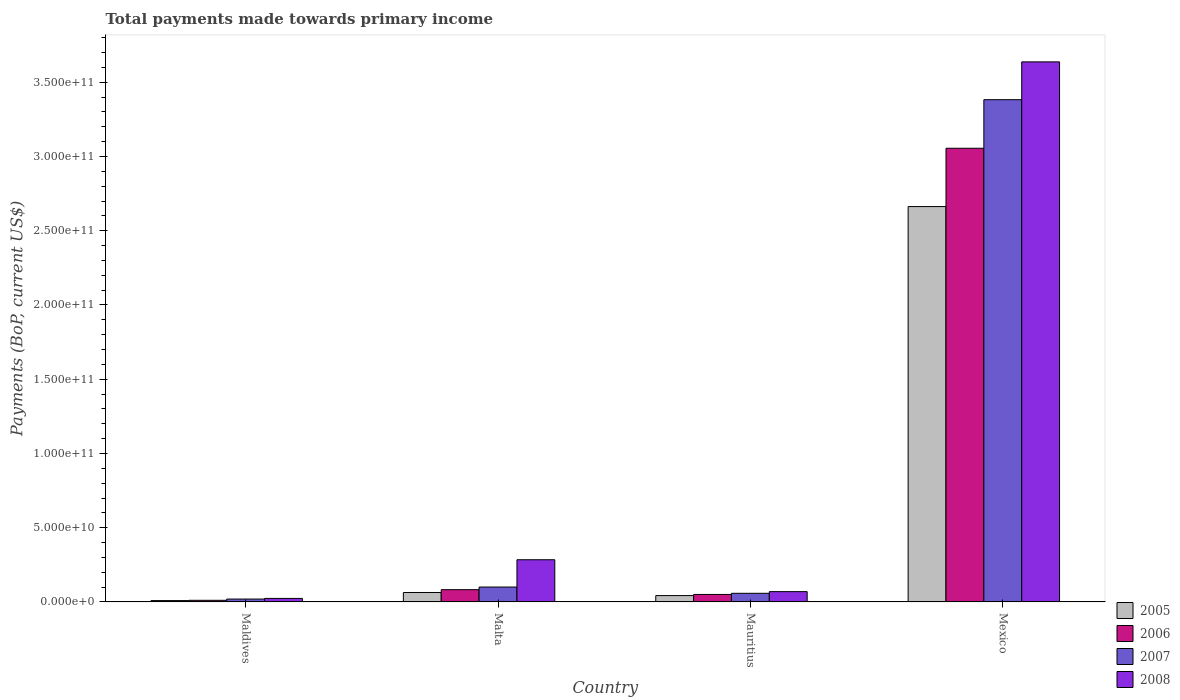How many different coloured bars are there?
Offer a very short reply. 4. How many groups of bars are there?
Give a very brief answer. 4. Are the number of bars on each tick of the X-axis equal?
Give a very brief answer. Yes. How many bars are there on the 4th tick from the left?
Offer a terse response. 4. How many bars are there on the 1st tick from the right?
Offer a terse response. 4. What is the label of the 3rd group of bars from the left?
Your answer should be compact. Mauritius. What is the total payments made towards primary income in 2007 in Malta?
Keep it short and to the point. 1.00e+1. Across all countries, what is the maximum total payments made towards primary income in 2007?
Your answer should be very brief. 3.38e+11. Across all countries, what is the minimum total payments made towards primary income in 2007?
Your answer should be very brief. 1.94e+09. In which country was the total payments made towards primary income in 2005 minimum?
Keep it short and to the point. Maldives. What is the total total payments made towards primary income in 2005 in the graph?
Make the answer very short. 2.78e+11. What is the difference between the total payments made towards primary income in 2007 in Maldives and that in Mexico?
Make the answer very short. -3.36e+11. What is the difference between the total payments made towards primary income in 2006 in Malta and the total payments made towards primary income in 2008 in Mauritius?
Offer a terse response. 1.32e+09. What is the average total payments made towards primary income in 2006 per country?
Make the answer very short. 8.00e+1. What is the difference between the total payments made towards primary income of/in 2005 and total payments made towards primary income of/in 2006 in Mexico?
Your response must be concise. -3.93e+1. In how many countries, is the total payments made towards primary income in 2006 greater than 10000000000 US$?
Provide a succinct answer. 1. What is the ratio of the total payments made towards primary income in 2008 in Maldives to that in Mexico?
Give a very brief answer. 0.01. What is the difference between the highest and the second highest total payments made towards primary income in 2006?
Ensure brevity in your answer.  -3.01e+11. What is the difference between the highest and the lowest total payments made towards primary income in 2008?
Provide a succinct answer. 3.61e+11. Is the sum of the total payments made towards primary income in 2005 in Malta and Mexico greater than the maximum total payments made towards primary income in 2006 across all countries?
Your response must be concise. No. Is it the case that in every country, the sum of the total payments made towards primary income in 2005 and total payments made towards primary income in 2006 is greater than the total payments made towards primary income in 2008?
Give a very brief answer. No. How many bars are there?
Ensure brevity in your answer.  16. Are all the bars in the graph horizontal?
Keep it short and to the point. No. How many countries are there in the graph?
Your answer should be compact. 4. Does the graph contain any zero values?
Ensure brevity in your answer.  No. Where does the legend appear in the graph?
Your answer should be very brief. Bottom right. What is the title of the graph?
Your response must be concise. Total payments made towards primary income. Does "1971" appear as one of the legend labels in the graph?
Make the answer very short. No. What is the label or title of the Y-axis?
Ensure brevity in your answer.  Payments (BoP, current US$). What is the Payments (BoP, current US$) in 2005 in Maldives?
Give a very brief answer. 9.10e+08. What is the Payments (BoP, current US$) in 2006 in Maldives?
Provide a short and direct response. 1.10e+09. What is the Payments (BoP, current US$) in 2007 in Maldives?
Provide a short and direct response. 1.94e+09. What is the Payments (BoP, current US$) in 2008 in Maldives?
Give a very brief answer. 2.38e+09. What is the Payments (BoP, current US$) in 2005 in Malta?
Provide a succinct answer. 6.37e+09. What is the Payments (BoP, current US$) of 2006 in Malta?
Offer a terse response. 8.26e+09. What is the Payments (BoP, current US$) in 2007 in Malta?
Give a very brief answer. 1.00e+1. What is the Payments (BoP, current US$) in 2008 in Malta?
Ensure brevity in your answer.  2.84e+1. What is the Payments (BoP, current US$) of 2005 in Mauritius?
Your response must be concise. 4.28e+09. What is the Payments (BoP, current US$) of 2006 in Mauritius?
Give a very brief answer. 5.05e+09. What is the Payments (BoP, current US$) of 2007 in Mauritius?
Your response must be concise. 5.82e+09. What is the Payments (BoP, current US$) in 2008 in Mauritius?
Your answer should be very brief. 6.95e+09. What is the Payments (BoP, current US$) in 2005 in Mexico?
Your response must be concise. 2.66e+11. What is the Payments (BoP, current US$) of 2006 in Mexico?
Provide a short and direct response. 3.06e+11. What is the Payments (BoP, current US$) in 2007 in Mexico?
Keep it short and to the point. 3.38e+11. What is the Payments (BoP, current US$) of 2008 in Mexico?
Provide a short and direct response. 3.64e+11. Across all countries, what is the maximum Payments (BoP, current US$) of 2005?
Your answer should be compact. 2.66e+11. Across all countries, what is the maximum Payments (BoP, current US$) of 2006?
Make the answer very short. 3.06e+11. Across all countries, what is the maximum Payments (BoP, current US$) of 2007?
Make the answer very short. 3.38e+11. Across all countries, what is the maximum Payments (BoP, current US$) of 2008?
Offer a terse response. 3.64e+11. Across all countries, what is the minimum Payments (BoP, current US$) of 2005?
Ensure brevity in your answer.  9.10e+08. Across all countries, what is the minimum Payments (BoP, current US$) of 2006?
Your answer should be very brief. 1.10e+09. Across all countries, what is the minimum Payments (BoP, current US$) of 2007?
Provide a short and direct response. 1.94e+09. Across all countries, what is the minimum Payments (BoP, current US$) of 2008?
Your response must be concise. 2.38e+09. What is the total Payments (BoP, current US$) of 2005 in the graph?
Your answer should be very brief. 2.78e+11. What is the total Payments (BoP, current US$) in 2006 in the graph?
Your answer should be very brief. 3.20e+11. What is the total Payments (BoP, current US$) of 2007 in the graph?
Your answer should be very brief. 3.56e+11. What is the total Payments (BoP, current US$) of 2008 in the graph?
Ensure brevity in your answer.  4.01e+11. What is the difference between the Payments (BoP, current US$) in 2005 in Maldives and that in Malta?
Give a very brief answer. -5.46e+09. What is the difference between the Payments (BoP, current US$) of 2006 in Maldives and that in Malta?
Provide a succinct answer. -7.16e+09. What is the difference between the Payments (BoP, current US$) in 2007 in Maldives and that in Malta?
Ensure brevity in your answer.  -8.10e+09. What is the difference between the Payments (BoP, current US$) of 2008 in Maldives and that in Malta?
Your response must be concise. -2.60e+1. What is the difference between the Payments (BoP, current US$) in 2005 in Maldives and that in Mauritius?
Your answer should be very brief. -3.37e+09. What is the difference between the Payments (BoP, current US$) of 2006 in Maldives and that in Mauritius?
Your answer should be compact. -3.95e+09. What is the difference between the Payments (BoP, current US$) of 2007 in Maldives and that in Mauritius?
Your response must be concise. -3.88e+09. What is the difference between the Payments (BoP, current US$) of 2008 in Maldives and that in Mauritius?
Your answer should be very brief. -4.57e+09. What is the difference between the Payments (BoP, current US$) in 2005 in Maldives and that in Mexico?
Your answer should be very brief. -2.65e+11. What is the difference between the Payments (BoP, current US$) of 2006 in Maldives and that in Mexico?
Offer a very short reply. -3.04e+11. What is the difference between the Payments (BoP, current US$) in 2007 in Maldives and that in Mexico?
Keep it short and to the point. -3.36e+11. What is the difference between the Payments (BoP, current US$) of 2008 in Maldives and that in Mexico?
Offer a terse response. -3.61e+11. What is the difference between the Payments (BoP, current US$) of 2005 in Malta and that in Mauritius?
Your response must be concise. 2.08e+09. What is the difference between the Payments (BoP, current US$) in 2006 in Malta and that in Mauritius?
Provide a succinct answer. 3.21e+09. What is the difference between the Payments (BoP, current US$) in 2007 in Malta and that in Mauritius?
Your answer should be very brief. 4.22e+09. What is the difference between the Payments (BoP, current US$) of 2008 in Malta and that in Mauritius?
Your answer should be very brief. 2.15e+1. What is the difference between the Payments (BoP, current US$) in 2005 in Malta and that in Mexico?
Your answer should be compact. -2.60e+11. What is the difference between the Payments (BoP, current US$) in 2006 in Malta and that in Mexico?
Your answer should be compact. -2.97e+11. What is the difference between the Payments (BoP, current US$) of 2007 in Malta and that in Mexico?
Provide a succinct answer. -3.28e+11. What is the difference between the Payments (BoP, current US$) in 2008 in Malta and that in Mexico?
Offer a very short reply. -3.35e+11. What is the difference between the Payments (BoP, current US$) in 2005 in Mauritius and that in Mexico?
Offer a terse response. -2.62e+11. What is the difference between the Payments (BoP, current US$) of 2006 in Mauritius and that in Mexico?
Provide a short and direct response. -3.01e+11. What is the difference between the Payments (BoP, current US$) in 2007 in Mauritius and that in Mexico?
Provide a short and direct response. -3.32e+11. What is the difference between the Payments (BoP, current US$) in 2008 in Mauritius and that in Mexico?
Ensure brevity in your answer.  -3.57e+11. What is the difference between the Payments (BoP, current US$) of 2005 in Maldives and the Payments (BoP, current US$) of 2006 in Malta?
Give a very brief answer. -7.35e+09. What is the difference between the Payments (BoP, current US$) in 2005 in Maldives and the Payments (BoP, current US$) in 2007 in Malta?
Keep it short and to the point. -9.13e+09. What is the difference between the Payments (BoP, current US$) of 2005 in Maldives and the Payments (BoP, current US$) of 2008 in Malta?
Your answer should be compact. -2.75e+1. What is the difference between the Payments (BoP, current US$) of 2006 in Maldives and the Payments (BoP, current US$) of 2007 in Malta?
Provide a succinct answer. -8.94e+09. What is the difference between the Payments (BoP, current US$) of 2006 in Maldives and the Payments (BoP, current US$) of 2008 in Malta?
Offer a terse response. -2.73e+1. What is the difference between the Payments (BoP, current US$) in 2007 in Maldives and the Payments (BoP, current US$) in 2008 in Malta?
Make the answer very short. -2.65e+1. What is the difference between the Payments (BoP, current US$) in 2005 in Maldives and the Payments (BoP, current US$) in 2006 in Mauritius?
Provide a succinct answer. -4.14e+09. What is the difference between the Payments (BoP, current US$) in 2005 in Maldives and the Payments (BoP, current US$) in 2007 in Mauritius?
Provide a short and direct response. -4.91e+09. What is the difference between the Payments (BoP, current US$) of 2005 in Maldives and the Payments (BoP, current US$) of 2008 in Mauritius?
Offer a terse response. -6.04e+09. What is the difference between the Payments (BoP, current US$) of 2006 in Maldives and the Payments (BoP, current US$) of 2007 in Mauritius?
Provide a short and direct response. -4.72e+09. What is the difference between the Payments (BoP, current US$) in 2006 in Maldives and the Payments (BoP, current US$) in 2008 in Mauritius?
Ensure brevity in your answer.  -5.84e+09. What is the difference between the Payments (BoP, current US$) of 2007 in Maldives and the Payments (BoP, current US$) of 2008 in Mauritius?
Provide a short and direct response. -5.00e+09. What is the difference between the Payments (BoP, current US$) in 2005 in Maldives and the Payments (BoP, current US$) in 2006 in Mexico?
Your response must be concise. -3.05e+11. What is the difference between the Payments (BoP, current US$) in 2005 in Maldives and the Payments (BoP, current US$) in 2007 in Mexico?
Your response must be concise. -3.37e+11. What is the difference between the Payments (BoP, current US$) in 2005 in Maldives and the Payments (BoP, current US$) in 2008 in Mexico?
Your answer should be very brief. -3.63e+11. What is the difference between the Payments (BoP, current US$) in 2006 in Maldives and the Payments (BoP, current US$) in 2007 in Mexico?
Provide a succinct answer. -3.37e+11. What is the difference between the Payments (BoP, current US$) in 2006 in Maldives and the Payments (BoP, current US$) in 2008 in Mexico?
Offer a terse response. -3.63e+11. What is the difference between the Payments (BoP, current US$) of 2007 in Maldives and the Payments (BoP, current US$) of 2008 in Mexico?
Offer a very short reply. -3.62e+11. What is the difference between the Payments (BoP, current US$) in 2005 in Malta and the Payments (BoP, current US$) in 2006 in Mauritius?
Ensure brevity in your answer.  1.32e+09. What is the difference between the Payments (BoP, current US$) of 2005 in Malta and the Payments (BoP, current US$) of 2007 in Mauritius?
Ensure brevity in your answer.  5.49e+08. What is the difference between the Payments (BoP, current US$) of 2005 in Malta and the Payments (BoP, current US$) of 2008 in Mauritius?
Your answer should be very brief. -5.81e+08. What is the difference between the Payments (BoP, current US$) of 2006 in Malta and the Payments (BoP, current US$) of 2007 in Mauritius?
Provide a short and direct response. 2.45e+09. What is the difference between the Payments (BoP, current US$) of 2006 in Malta and the Payments (BoP, current US$) of 2008 in Mauritius?
Your answer should be very brief. 1.32e+09. What is the difference between the Payments (BoP, current US$) in 2007 in Malta and the Payments (BoP, current US$) in 2008 in Mauritius?
Provide a short and direct response. 3.09e+09. What is the difference between the Payments (BoP, current US$) in 2005 in Malta and the Payments (BoP, current US$) in 2006 in Mexico?
Keep it short and to the point. -2.99e+11. What is the difference between the Payments (BoP, current US$) of 2005 in Malta and the Payments (BoP, current US$) of 2007 in Mexico?
Give a very brief answer. -3.32e+11. What is the difference between the Payments (BoP, current US$) in 2005 in Malta and the Payments (BoP, current US$) in 2008 in Mexico?
Ensure brevity in your answer.  -3.57e+11. What is the difference between the Payments (BoP, current US$) in 2006 in Malta and the Payments (BoP, current US$) in 2007 in Mexico?
Provide a succinct answer. -3.30e+11. What is the difference between the Payments (BoP, current US$) in 2006 in Malta and the Payments (BoP, current US$) in 2008 in Mexico?
Ensure brevity in your answer.  -3.55e+11. What is the difference between the Payments (BoP, current US$) of 2007 in Malta and the Payments (BoP, current US$) of 2008 in Mexico?
Your response must be concise. -3.54e+11. What is the difference between the Payments (BoP, current US$) of 2005 in Mauritius and the Payments (BoP, current US$) of 2006 in Mexico?
Keep it short and to the point. -3.01e+11. What is the difference between the Payments (BoP, current US$) in 2005 in Mauritius and the Payments (BoP, current US$) in 2007 in Mexico?
Your answer should be compact. -3.34e+11. What is the difference between the Payments (BoP, current US$) of 2005 in Mauritius and the Payments (BoP, current US$) of 2008 in Mexico?
Keep it short and to the point. -3.59e+11. What is the difference between the Payments (BoP, current US$) of 2006 in Mauritius and the Payments (BoP, current US$) of 2007 in Mexico?
Keep it short and to the point. -3.33e+11. What is the difference between the Payments (BoP, current US$) of 2006 in Mauritius and the Payments (BoP, current US$) of 2008 in Mexico?
Make the answer very short. -3.59e+11. What is the difference between the Payments (BoP, current US$) in 2007 in Mauritius and the Payments (BoP, current US$) in 2008 in Mexico?
Ensure brevity in your answer.  -3.58e+11. What is the average Payments (BoP, current US$) in 2005 per country?
Make the answer very short. 6.95e+1. What is the average Payments (BoP, current US$) in 2006 per country?
Give a very brief answer. 8.00e+1. What is the average Payments (BoP, current US$) of 2007 per country?
Offer a terse response. 8.90e+1. What is the average Payments (BoP, current US$) in 2008 per country?
Offer a very short reply. 1.00e+11. What is the difference between the Payments (BoP, current US$) of 2005 and Payments (BoP, current US$) of 2006 in Maldives?
Make the answer very short. -1.92e+08. What is the difference between the Payments (BoP, current US$) of 2005 and Payments (BoP, current US$) of 2007 in Maldives?
Your answer should be very brief. -1.03e+09. What is the difference between the Payments (BoP, current US$) in 2005 and Payments (BoP, current US$) in 2008 in Maldives?
Make the answer very short. -1.47e+09. What is the difference between the Payments (BoP, current US$) of 2006 and Payments (BoP, current US$) of 2007 in Maldives?
Offer a very short reply. -8.40e+08. What is the difference between the Payments (BoP, current US$) of 2006 and Payments (BoP, current US$) of 2008 in Maldives?
Provide a succinct answer. -1.28e+09. What is the difference between the Payments (BoP, current US$) of 2007 and Payments (BoP, current US$) of 2008 in Maldives?
Offer a terse response. -4.38e+08. What is the difference between the Payments (BoP, current US$) of 2005 and Payments (BoP, current US$) of 2006 in Malta?
Your response must be concise. -1.90e+09. What is the difference between the Payments (BoP, current US$) in 2005 and Payments (BoP, current US$) in 2007 in Malta?
Offer a terse response. -3.67e+09. What is the difference between the Payments (BoP, current US$) in 2005 and Payments (BoP, current US$) in 2008 in Malta?
Your response must be concise. -2.21e+1. What is the difference between the Payments (BoP, current US$) of 2006 and Payments (BoP, current US$) of 2007 in Malta?
Offer a terse response. -1.78e+09. What is the difference between the Payments (BoP, current US$) of 2006 and Payments (BoP, current US$) of 2008 in Malta?
Your response must be concise. -2.02e+1. What is the difference between the Payments (BoP, current US$) in 2007 and Payments (BoP, current US$) in 2008 in Malta?
Your response must be concise. -1.84e+1. What is the difference between the Payments (BoP, current US$) in 2005 and Payments (BoP, current US$) in 2006 in Mauritius?
Your response must be concise. -7.65e+08. What is the difference between the Payments (BoP, current US$) in 2005 and Payments (BoP, current US$) in 2007 in Mauritius?
Your response must be concise. -1.53e+09. What is the difference between the Payments (BoP, current US$) of 2005 and Payments (BoP, current US$) of 2008 in Mauritius?
Offer a very short reply. -2.66e+09. What is the difference between the Payments (BoP, current US$) in 2006 and Payments (BoP, current US$) in 2007 in Mauritius?
Offer a very short reply. -7.69e+08. What is the difference between the Payments (BoP, current US$) of 2006 and Payments (BoP, current US$) of 2008 in Mauritius?
Provide a succinct answer. -1.90e+09. What is the difference between the Payments (BoP, current US$) of 2007 and Payments (BoP, current US$) of 2008 in Mauritius?
Ensure brevity in your answer.  -1.13e+09. What is the difference between the Payments (BoP, current US$) in 2005 and Payments (BoP, current US$) in 2006 in Mexico?
Your answer should be very brief. -3.93e+1. What is the difference between the Payments (BoP, current US$) of 2005 and Payments (BoP, current US$) of 2007 in Mexico?
Offer a very short reply. -7.20e+1. What is the difference between the Payments (BoP, current US$) in 2005 and Payments (BoP, current US$) in 2008 in Mexico?
Provide a succinct answer. -9.74e+1. What is the difference between the Payments (BoP, current US$) of 2006 and Payments (BoP, current US$) of 2007 in Mexico?
Make the answer very short. -3.27e+1. What is the difference between the Payments (BoP, current US$) in 2006 and Payments (BoP, current US$) in 2008 in Mexico?
Offer a very short reply. -5.82e+1. What is the difference between the Payments (BoP, current US$) in 2007 and Payments (BoP, current US$) in 2008 in Mexico?
Provide a succinct answer. -2.55e+1. What is the ratio of the Payments (BoP, current US$) in 2005 in Maldives to that in Malta?
Ensure brevity in your answer.  0.14. What is the ratio of the Payments (BoP, current US$) of 2006 in Maldives to that in Malta?
Your response must be concise. 0.13. What is the ratio of the Payments (BoP, current US$) of 2007 in Maldives to that in Malta?
Your response must be concise. 0.19. What is the ratio of the Payments (BoP, current US$) in 2008 in Maldives to that in Malta?
Your answer should be compact. 0.08. What is the ratio of the Payments (BoP, current US$) in 2005 in Maldives to that in Mauritius?
Your answer should be very brief. 0.21. What is the ratio of the Payments (BoP, current US$) in 2006 in Maldives to that in Mauritius?
Give a very brief answer. 0.22. What is the ratio of the Payments (BoP, current US$) of 2007 in Maldives to that in Mauritius?
Give a very brief answer. 0.33. What is the ratio of the Payments (BoP, current US$) of 2008 in Maldives to that in Mauritius?
Ensure brevity in your answer.  0.34. What is the ratio of the Payments (BoP, current US$) of 2005 in Maldives to that in Mexico?
Offer a very short reply. 0. What is the ratio of the Payments (BoP, current US$) in 2006 in Maldives to that in Mexico?
Provide a succinct answer. 0. What is the ratio of the Payments (BoP, current US$) in 2007 in Maldives to that in Mexico?
Offer a very short reply. 0.01. What is the ratio of the Payments (BoP, current US$) in 2008 in Maldives to that in Mexico?
Your answer should be very brief. 0.01. What is the ratio of the Payments (BoP, current US$) in 2005 in Malta to that in Mauritius?
Your response must be concise. 1.49. What is the ratio of the Payments (BoP, current US$) in 2006 in Malta to that in Mauritius?
Your response must be concise. 1.64. What is the ratio of the Payments (BoP, current US$) of 2007 in Malta to that in Mauritius?
Make the answer very short. 1.73. What is the ratio of the Payments (BoP, current US$) of 2008 in Malta to that in Mauritius?
Provide a succinct answer. 4.09. What is the ratio of the Payments (BoP, current US$) in 2005 in Malta to that in Mexico?
Your answer should be very brief. 0.02. What is the ratio of the Payments (BoP, current US$) of 2006 in Malta to that in Mexico?
Give a very brief answer. 0.03. What is the ratio of the Payments (BoP, current US$) in 2007 in Malta to that in Mexico?
Provide a short and direct response. 0.03. What is the ratio of the Payments (BoP, current US$) in 2008 in Malta to that in Mexico?
Offer a terse response. 0.08. What is the ratio of the Payments (BoP, current US$) in 2005 in Mauritius to that in Mexico?
Offer a terse response. 0.02. What is the ratio of the Payments (BoP, current US$) in 2006 in Mauritius to that in Mexico?
Give a very brief answer. 0.02. What is the ratio of the Payments (BoP, current US$) in 2007 in Mauritius to that in Mexico?
Provide a succinct answer. 0.02. What is the ratio of the Payments (BoP, current US$) in 2008 in Mauritius to that in Mexico?
Provide a short and direct response. 0.02. What is the difference between the highest and the second highest Payments (BoP, current US$) in 2005?
Your answer should be very brief. 2.60e+11. What is the difference between the highest and the second highest Payments (BoP, current US$) in 2006?
Give a very brief answer. 2.97e+11. What is the difference between the highest and the second highest Payments (BoP, current US$) in 2007?
Give a very brief answer. 3.28e+11. What is the difference between the highest and the second highest Payments (BoP, current US$) in 2008?
Keep it short and to the point. 3.35e+11. What is the difference between the highest and the lowest Payments (BoP, current US$) in 2005?
Make the answer very short. 2.65e+11. What is the difference between the highest and the lowest Payments (BoP, current US$) of 2006?
Your answer should be compact. 3.04e+11. What is the difference between the highest and the lowest Payments (BoP, current US$) in 2007?
Provide a succinct answer. 3.36e+11. What is the difference between the highest and the lowest Payments (BoP, current US$) of 2008?
Make the answer very short. 3.61e+11. 